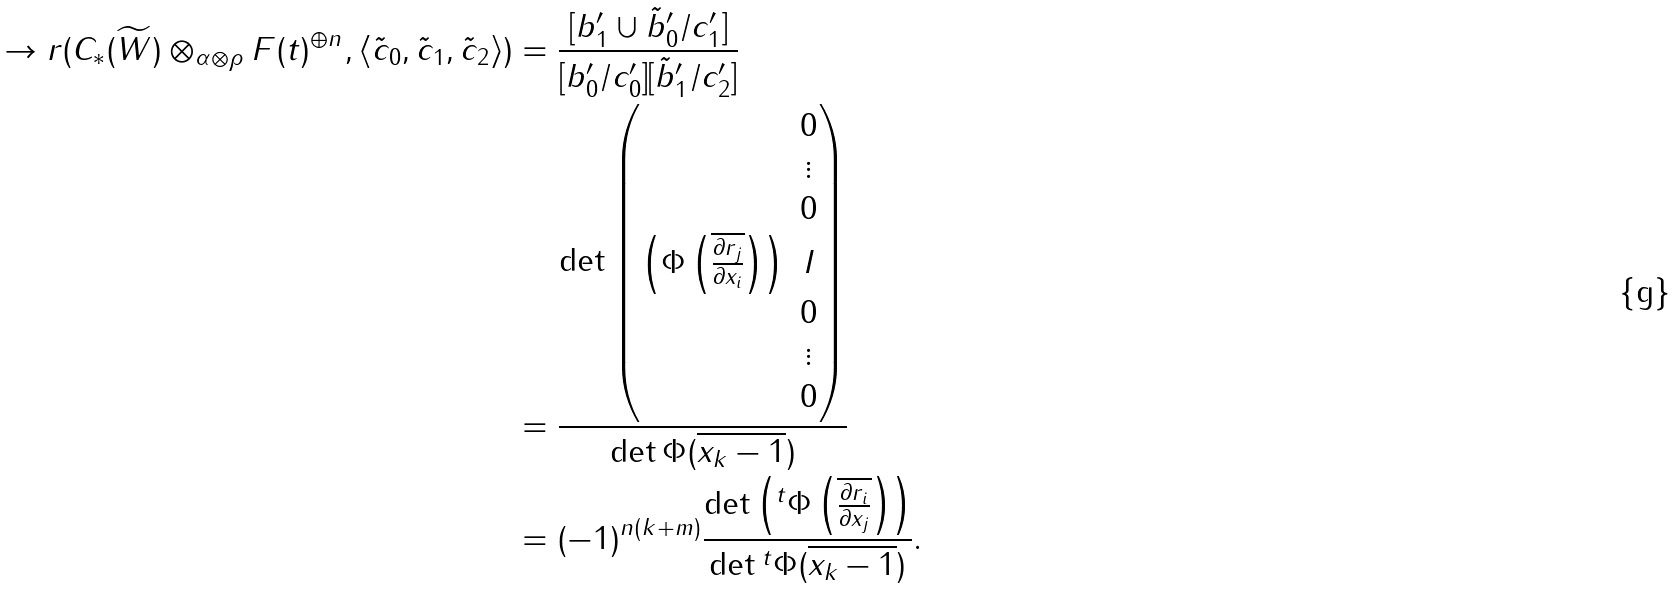Convert formula to latex. <formula><loc_0><loc_0><loc_500><loc_500>\to r ( C _ { * } ( \widetilde { W } ) \otimes _ { \alpha \otimes \rho } F ( t ) ^ { \oplus n } , \langle \tilde { c } _ { 0 } , \tilde { c } _ { 1 } , \tilde { c } _ { 2 } \rangle ) & = \frac { [ b _ { 1 } ^ { \prime } \cup \tilde { b } _ { 0 } ^ { \prime } / c _ { 1 } ^ { \prime } ] } { [ b _ { 0 } ^ { \prime } / c _ { 0 } ^ { \prime } ] [ \tilde { b } _ { 1 } ^ { \prime } / c _ { 2 } ^ { \prime } ] } \\ & = \frac { \det \begin{pmatrix} & 0 \\ & \vdots \\ & 0 \\ \left ( \Phi \left ( \overline { \frac { \partial r _ { j } } { \partial x _ { i } } } \right ) \right ) & I \\ & 0 \\ & \vdots \\ & 0 \end{pmatrix} } { \det \Phi ( \overline { x _ { k } - 1 } ) } \\ & = ( - 1 ) ^ { n ( k + m ) } \frac { \det \left ( { ^ { t } \Phi \left ( \overline { \frac { \partial r _ { i } } { \partial x _ { j } } } \right ) } \right ) } { \det { ^ { t } \Phi ( \overline { x _ { k } - 1 } ) } } .</formula> 